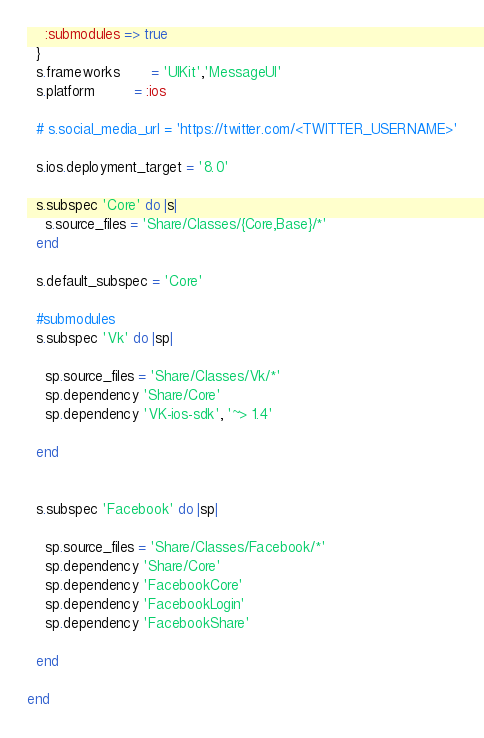Convert code to text. <code><loc_0><loc_0><loc_500><loc_500><_Ruby_>    :submodules => true
  }
  s.frameworks       = 'UIKit','MessageUI'
  s.platform         = :ios

  # s.social_media_url = 'https://twitter.com/<TWITTER_USERNAME>'

  s.ios.deployment_target = '8.0'

  s.subspec 'Core' do |s|
    s.source_files = 'Share/Classes/{Core,Base}/*'
  end

  s.default_subspec = 'Core'

  #submodules
  s.subspec 'Vk' do |sp|

    sp.source_files = 'Share/Classes/Vk/*'
    sp.dependency 'Share/Core'
    sp.dependency 'VK-ios-sdk', '~> 1.4'

  end


  s.subspec 'Facebook' do |sp|

    sp.source_files = 'Share/Classes/Facebook/*'
    sp.dependency 'Share/Core'
    sp.dependency 'FacebookCore'
    sp.dependency 'FacebookLogin'
    sp.dependency 'FacebookShare'

  end

end
</code> 